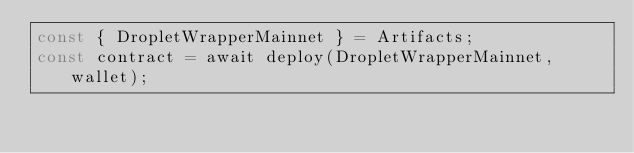Convert code to text. <code><loc_0><loc_0><loc_500><loc_500><_JavaScript_>const { DropletWrapperMainnet } = Artifacts;
const contract = await deploy(DropletWrapperMainnet, wallet);
</code> 